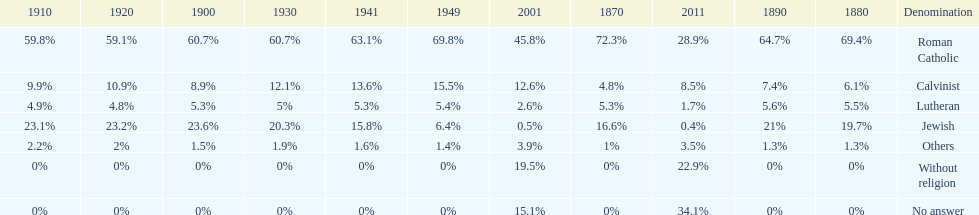Which denomination has the highest margin? Roman Catholic. 